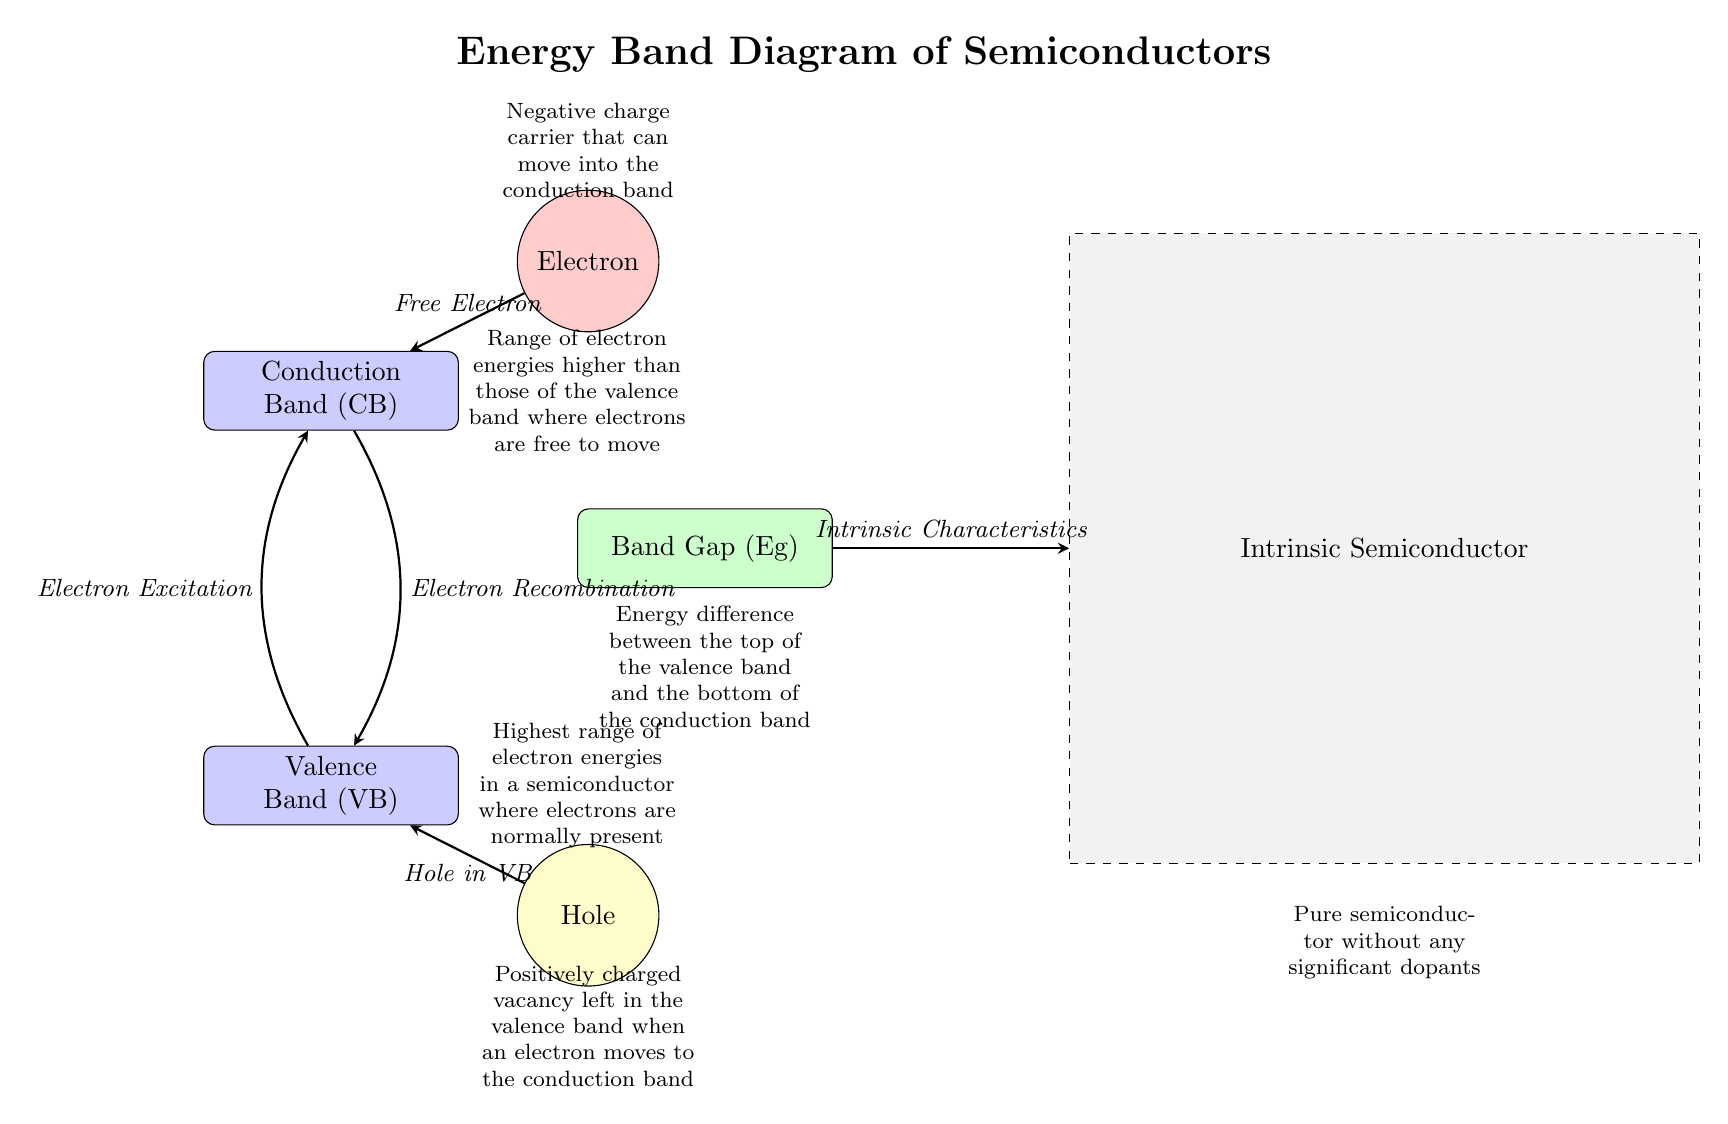What are the two main energy bands shown in the diagram? The diagram clearly labels the two main energy bands as the "Conduction Band" and "Valence Band". Hence, these terms represent the main energy levels outlined in the diagram.
Answer: Conduction Band, Valence Band What is the color of the Band Gap in the diagram? The Band Gap is highlighted with a green shade according to the style parameters defined in the TikZ code, making it identifiable through its color.
Answer: Green How many particles are represented in the diagram? There are two particles depicted: an Electron (in red) and a Hole (in yellow) as per the distinct particle attributes given in the code.
Answer: Two What does the arrow from the Valence Band to the Conduction Band signify? The arrow from the Valence Band to the Conduction Band indicates "Electron Excitation", which suggests the transition of electrons from one band to another due to energy input.
Answer: Electron Excitation What is the definition of the Band Gap as per the diagram? The diagram states the Band Gap is described as the "Energy difference between the top of the valence band and the bottom of the conduction band", succinctly summarizing its role in semiconductor physics.
Answer: Energy difference between the top of the valence band and the bottom of the conduction band What type of semiconductor is depicted in the right part of the diagram? The rightmost section of the diagram specifies an "Intrinsic Semiconductor", indicating that it is a pure semiconductor without significant dopants as shown within the boundaries of the marked area.
Answer: Intrinsic Semiconductor What charge does the Electron represent in the diagram? The Electron is indicated to have a "Negative charge carrier" notation within the diagram description, defining its electrical properties as associated with negative charge.
Answer: Negative What is indicated by the arrow from the Conduction Band back to the Valence Band? The arrow represents "Electron Recombination", which illustrates the process of an electron moving back into the valence band, thus highlighting transitions between energy states.
Answer: Electron Recombination How is the energy level range of the Conduction Band described? The diagram characterizes the Conduction Band as being "Range of electron energies higher than those of the valence band where electrons are free to move", clearly stating its function and definition.
Answer: Range of electron energies higher than those of the valence band where electrons are free to move 